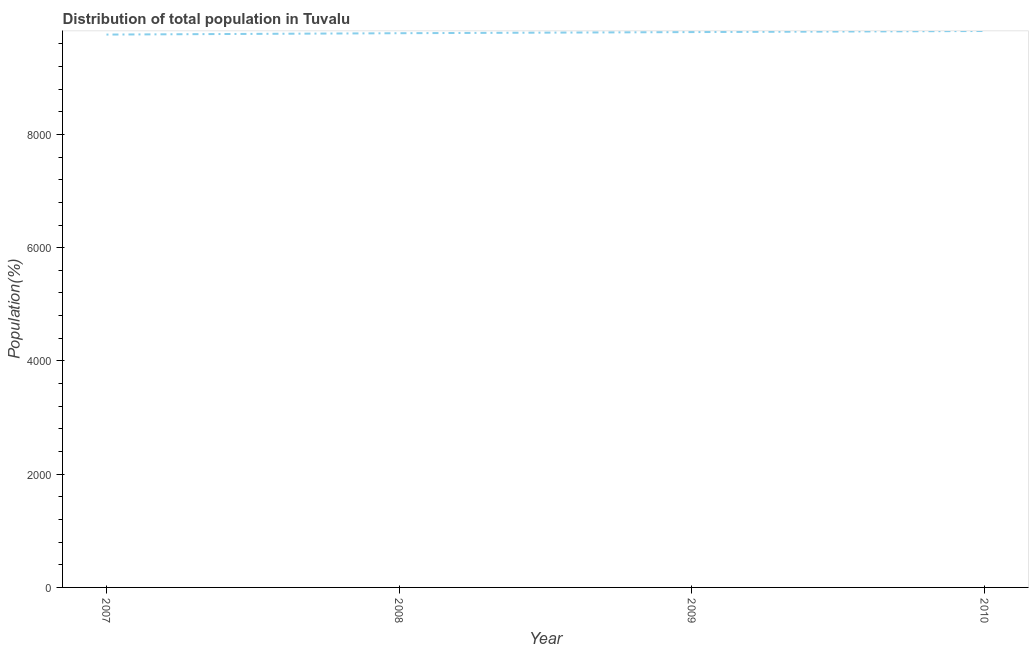What is the population in 2008?
Your answer should be compact. 9788. Across all years, what is the maximum population?
Your answer should be compact. 9827. Across all years, what is the minimum population?
Ensure brevity in your answer.  9764. In which year was the population maximum?
Your response must be concise. 2010. In which year was the population minimum?
Provide a succinct answer. 2007. What is the sum of the population?
Make the answer very short. 3.92e+04. What is the difference between the population in 2007 and 2010?
Your answer should be compact. -63. What is the average population per year?
Provide a succinct answer. 9796.75. What is the median population?
Give a very brief answer. 9798. In how many years, is the population greater than 4800 %?
Your response must be concise. 4. Do a majority of the years between 2009 and 2010 (inclusive) have population greater than 2000 %?
Provide a short and direct response. Yes. What is the ratio of the population in 2009 to that in 2010?
Provide a short and direct response. 1. Is the population in 2007 less than that in 2008?
Make the answer very short. Yes. What is the difference between the highest and the lowest population?
Provide a short and direct response. 63. In how many years, is the population greater than the average population taken over all years?
Your answer should be compact. 2. Does the population monotonically increase over the years?
Keep it short and to the point. Yes. What is the difference between two consecutive major ticks on the Y-axis?
Ensure brevity in your answer.  2000. Does the graph contain any zero values?
Provide a short and direct response. No. Does the graph contain grids?
Offer a very short reply. No. What is the title of the graph?
Give a very brief answer. Distribution of total population in Tuvalu . What is the label or title of the Y-axis?
Provide a succinct answer. Population(%). What is the Population(%) of 2007?
Offer a terse response. 9764. What is the Population(%) of 2008?
Your answer should be very brief. 9788. What is the Population(%) in 2009?
Give a very brief answer. 9808. What is the Population(%) of 2010?
Your answer should be very brief. 9827. What is the difference between the Population(%) in 2007 and 2009?
Make the answer very short. -44. What is the difference between the Population(%) in 2007 and 2010?
Provide a succinct answer. -63. What is the difference between the Population(%) in 2008 and 2010?
Offer a very short reply. -39. What is the ratio of the Population(%) in 2007 to that in 2008?
Make the answer very short. 1. What is the ratio of the Population(%) in 2007 to that in 2009?
Ensure brevity in your answer.  1. What is the ratio of the Population(%) in 2008 to that in 2010?
Provide a succinct answer. 1. What is the ratio of the Population(%) in 2009 to that in 2010?
Your response must be concise. 1. 